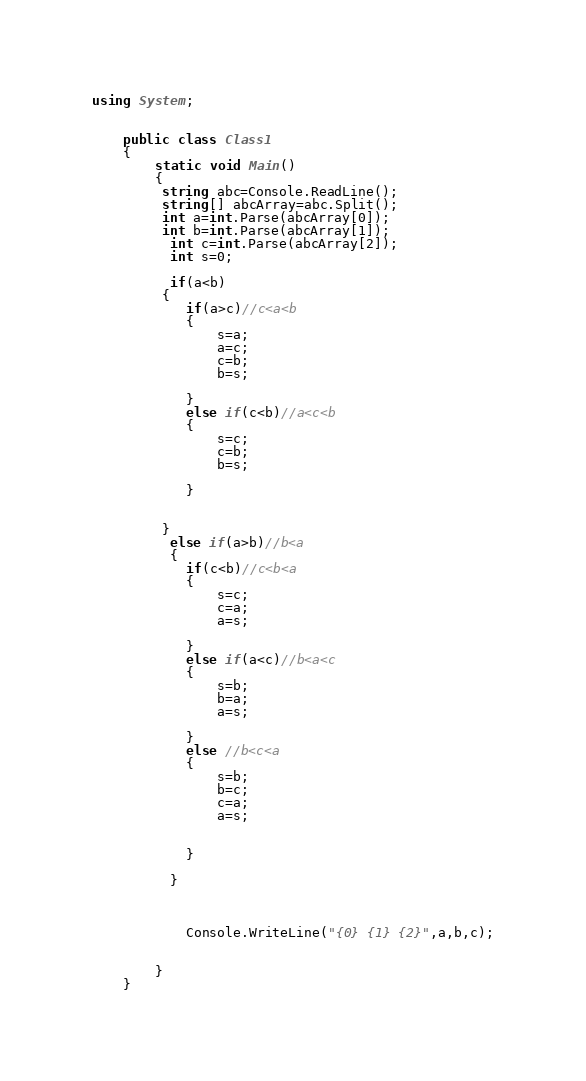Convert code to text. <code><loc_0><loc_0><loc_500><loc_500><_C#_>using System;

	
	public class Class1
	{
		static void Main()
		{
		 string abc=Console.ReadLine();
		 string[] abcArray=abc.Split();
		 int a=int.Parse(abcArray[0]);
		 int b=int.Parse(abcArray[1]);
		  int c=int.Parse(abcArray[2]);
		  int s=0;
		  
		  if(a<b)
		 {
		  	if(a>c)//c<a<b
		  	{
		  		s=a;
		  		a=c;
		  		c=b;
		  		b=s;
		  		
		  	}
		  	else if(c<b)//a<c<b
		  	{
		  		s=c;
		  		c=b;
		  		b=s;
		  		
		  	}
		  	
		  	
		 }
		  else if(a>b)//b<a
		  {
		  	if(c<b)//c<b<a
		  	{
		  		s=c;
		  		c=a;
		  		a=s;
		  		
		  	}
		  	else if(a<c)//b<a<c
		  	{
		  		s=b;
		  		b=a;
		  		a=s;
		  	
		  	}
		  	else //b<c<a
		  	{
		  		s=b;
		  		b=c;
		  		c=a;
		  		a=s;
		  		
		  		
		  	}
		  		
		  }
		  
		  	
		 
		 	Console.WriteLine("{0} {1} {2}",a,b,c);
		 
		
		}
	}</code> 